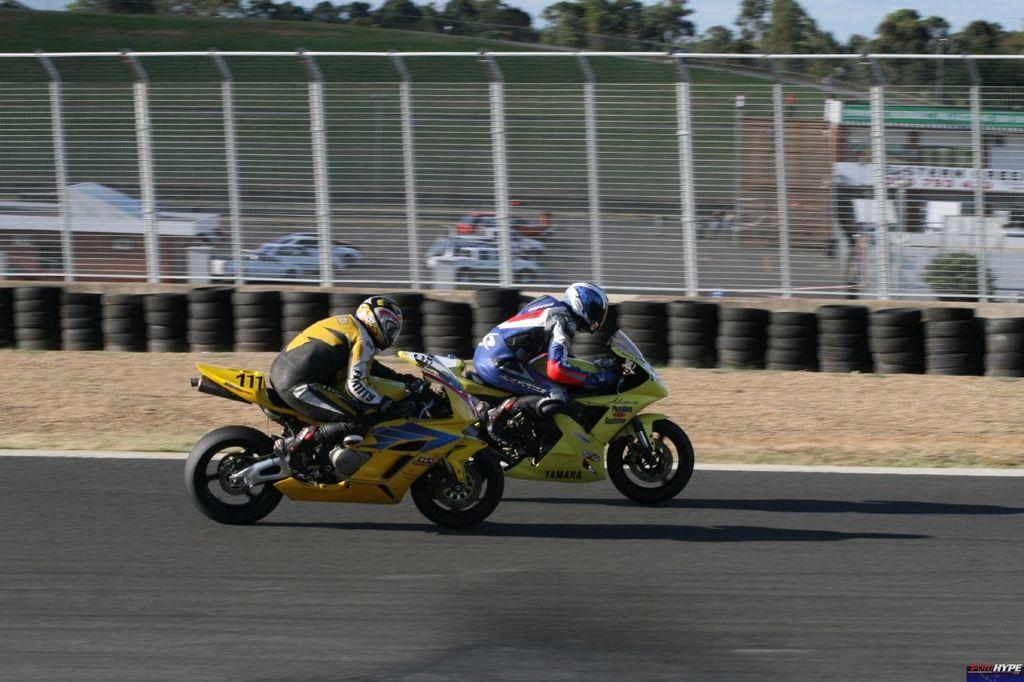How many people are in the image? There are two people in the image. What are the people wearing on their heads? Both people are wearing helmets. What are the people doing in the image? The people are riding motorbikes. Where are the motorbikes located? The motorbikes are on a road. What can be seen in the background of the image? There is a fence, trees, a building, and the sky visible in the background of the image. What other objects can be seen in the image? There are tyres and cars in the image, as well as other objects. What type of war is being fought in the image? There is no war depicted in the image; it features two people riding motorbikes on a road. What kind of love is being expressed between the two people in the image? There is no indication of love or affection between the two people in the image; they are simply riding motorbikes. 